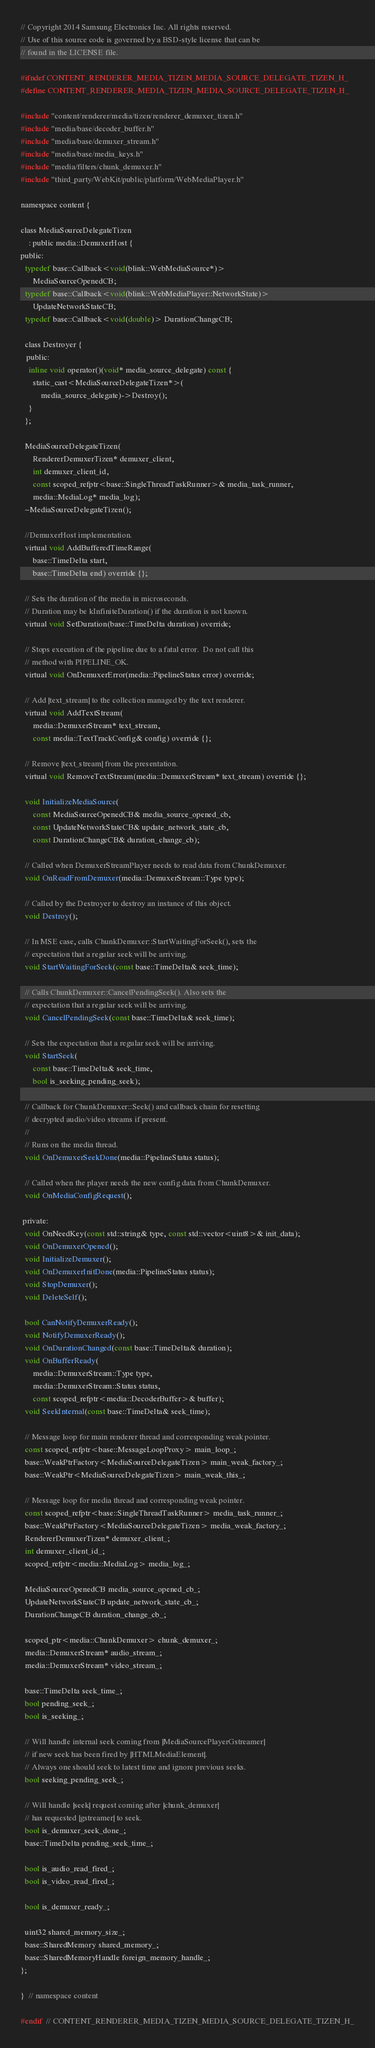Convert code to text. <code><loc_0><loc_0><loc_500><loc_500><_C_>// Copyright 2014 Samsung Electronics Inc. All rights reserved.
// Use of this source code is governed by a BSD-style license that can be
// found in the LICENSE file.

#ifndef CONTENT_RENDERER_MEDIA_TIZEN_MEDIA_SOURCE_DELEGATE_TIZEN_H_
#define CONTENT_RENDERER_MEDIA_TIZEN_MEDIA_SOURCE_DELEGATE_TIZEN_H_

#include "content/renderer/media/tizen/renderer_demuxer_tizen.h"
#include "media/base/decoder_buffer.h"
#include "media/base/demuxer_stream.h"
#include "media/base/media_keys.h"
#include "media/filters/chunk_demuxer.h"
#include "third_party/WebKit/public/platform/WebMediaPlayer.h"

namespace content {

class MediaSourceDelegateTizen
    : public media::DemuxerHost {
public:
  typedef base::Callback<void(blink::WebMediaSource*)>
      MediaSourceOpenedCB;
  typedef base::Callback<void(blink::WebMediaPlayer::NetworkState)>
      UpdateNetworkStateCB;
  typedef base::Callback<void(double)> DurationChangeCB;

  class Destroyer {
   public:
    inline void operator()(void* media_source_delegate) const {
      static_cast<MediaSourceDelegateTizen*>(
          media_source_delegate)->Destroy();
    }
  };

  MediaSourceDelegateTizen(
      RendererDemuxerTizen* demuxer_client,
      int demuxer_client_id,
      const scoped_refptr<base::SingleThreadTaskRunner>& media_task_runner,
      media::MediaLog* media_log);
  ~MediaSourceDelegateTizen();

  //DemuxerHost implementation.
  virtual void AddBufferedTimeRange(
      base::TimeDelta start,
      base::TimeDelta end) override {};

  // Sets the duration of the media in microseconds.
  // Duration may be kInfiniteDuration() if the duration is not known.
  virtual void SetDuration(base::TimeDelta duration) override;

  // Stops execution of the pipeline due to a fatal error.  Do not call this
  // method with PIPELINE_OK.
  virtual void OnDemuxerError(media::PipelineStatus error) override;

  // Add |text_stream| to the collection managed by the text renderer.
  virtual void AddTextStream(
      media::DemuxerStream* text_stream,
      const media::TextTrackConfig& config) override {};

  // Remove |text_stream| from the presentation.
  virtual void RemoveTextStream(media::DemuxerStream* text_stream) override {};

  void InitializeMediaSource(
      const MediaSourceOpenedCB& media_source_opened_cb,
      const UpdateNetworkStateCB& update_network_state_cb,
      const DurationChangeCB& duration_change_cb);

  // Called when DemuxerStreamPlayer needs to read data from ChunkDemuxer.
  void OnReadFromDemuxer(media::DemuxerStream::Type type);

  // Called by the Destroyer to destroy an instance of this object.
  void Destroy();

  // In MSE case, calls ChunkDemuxer::StartWaitingForSeek(), sets the
  // expectation that a regular seek will be arriving.
  void StartWaitingForSeek(const base::TimeDelta& seek_time);

  // Calls ChunkDemuxer::CancelPendingSeek(). Also sets the
  // expectation that a regular seek will be arriving.
  void CancelPendingSeek(const base::TimeDelta& seek_time);

  // Sets the expectation that a regular seek will be arriving.
  void StartSeek(
      const base::TimeDelta& seek_time,
      bool is_seeking_pending_seek);

  // Callback for ChunkDemuxer::Seek() and callback chain for resetting
  // decrypted audio/video streams if present.
  //
  // Runs on the media thread.
  void OnDemuxerSeekDone(media::PipelineStatus status);

  // Called when the player needs the new config data from ChunkDemuxer.
  void OnMediaConfigRequest();

 private:
  void OnNeedKey(const std::string& type, const std::vector<uint8>& init_data);
  void OnDemuxerOpened();
  void InitializeDemuxer();
  void OnDemuxerInitDone(media::PipelineStatus status);
  void StopDemuxer();
  void DeleteSelf();

  bool CanNotifyDemuxerReady();
  void NotifyDemuxerReady();
  void OnDurationChanged(const base::TimeDelta& duration);
  void OnBufferReady(
      media::DemuxerStream::Type type,
      media::DemuxerStream::Status status,
      const scoped_refptr<media::DecoderBuffer>& buffer);
  void SeekInternal(const base::TimeDelta& seek_time);

  // Message loop for main renderer thread and corresponding weak pointer.
  const scoped_refptr<base::MessageLoopProxy> main_loop_;
  base::WeakPtrFactory<MediaSourceDelegateTizen> main_weak_factory_;
  base::WeakPtr<MediaSourceDelegateTizen> main_weak_this_;

  // Message loop for media thread and corresponding weak pointer.
  const scoped_refptr<base::SingleThreadTaskRunner> media_task_runner_;
  base::WeakPtrFactory<MediaSourceDelegateTizen> media_weak_factory_;
  RendererDemuxerTizen* demuxer_client_;
  int demuxer_client_id_;
  scoped_refptr<media::MediaLog> media_log_;

  MediaSourceOpenedCB media_source_opened_cb_;
  UpdateNetworkStateCB update_network_state_cb_;
  DurationChangeCB duration_change_cb_;

  scoped_ptr<media::ChunkDemuxer> chunk_demuxer_;
  media::DemuxerStream* audio_stream_;
  media::DemuxerStream* video_stream_;

  base::TimeDelta seek_time_;
  bool pending_seek_;
  bool is_seeking_;

  // Will handle internal seek coming from |MediaSourcePlayerGstreamer|
  // if new seek has been fired by |HTMLMediaElement|.
  // Always one should seek to latest time and ignore previous seeks.
  bool seeking_pending_seek_;

  // Will handle |seek| request coming after |chunk_demuxer|
  // has requested |gstreamer| to seek.
  bool is_demuxer_seek_done_;
  base::TimeDelta pending_seek_time_;

  bool is_audio_read_fired_;
  bool is_video_read_fired_;

  bool is_demuxer_ready_;

  uint32 shared_memory_size_;
  base::SharedMemory shared_memory_;
  base::SharedMemoryHandle foreign_memory_handle_;
};

}  // namespace content

#endif  // CONTENT_RENDERER_MEDIA_TIZEN_MEDIA_SOURCE_DELEGATE_TIZEN_H_
</code> 